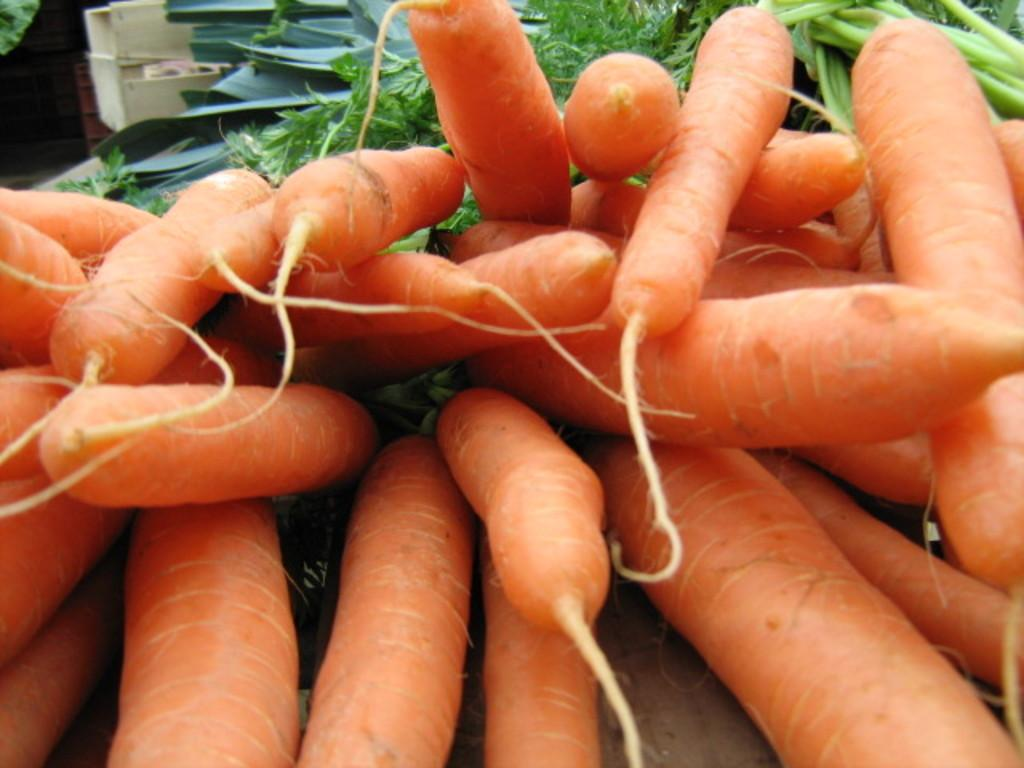What is the main subject in the front of the image? There is a fresher carat in the front of the image. What can be seen behind the carat in the image? There are green leafy vegetables behind the carat in the image. How many accounts are visible in the image? There are no accounts present in the image. What type of plantation can be seen in the background of the image? There is no plantation visible in the image; it only features a fresher carat and green leafy vegetables. 